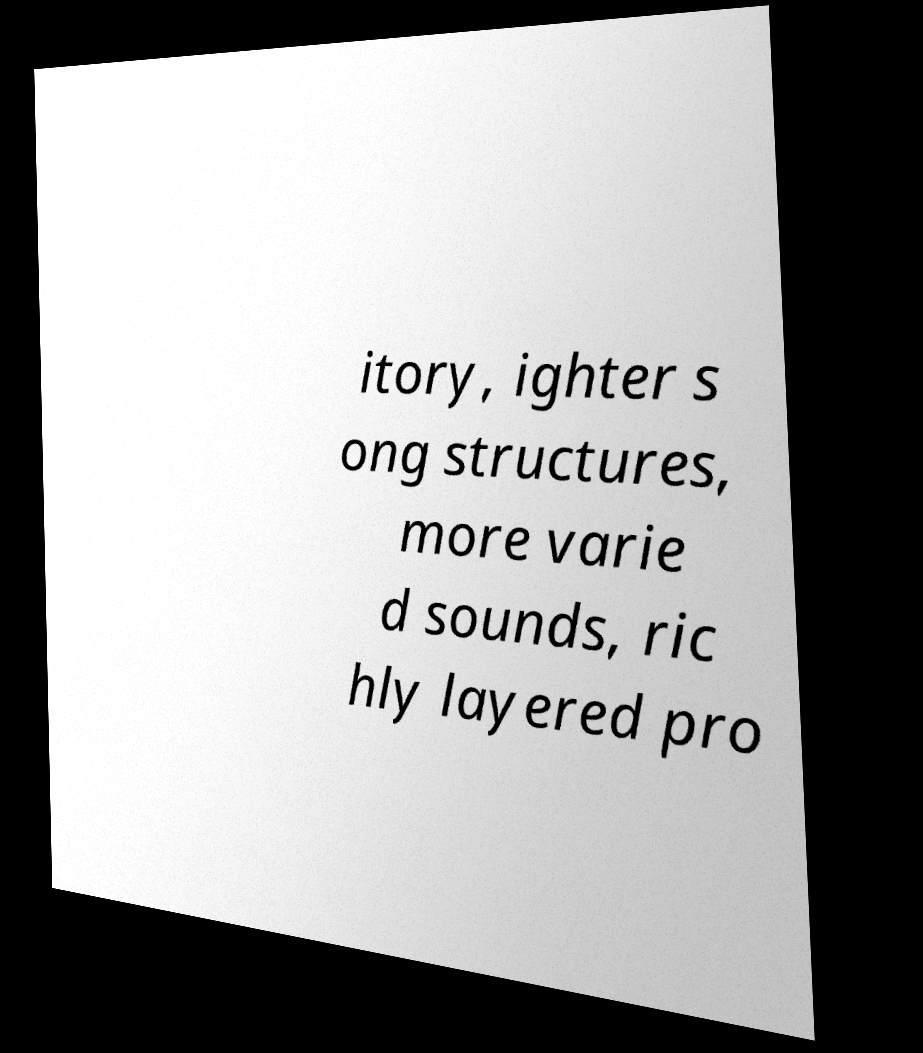Could you extract and type out the text from this image? itory, ighter s ong structures, more varie d sounds, ric hly layered pro 